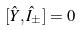Convert formula to latex. <formula><loc_0><loc_0><loc_500><loc_500>[ \hat { Y } , \hat { I } _ { \pm } ] = 0</formula> 